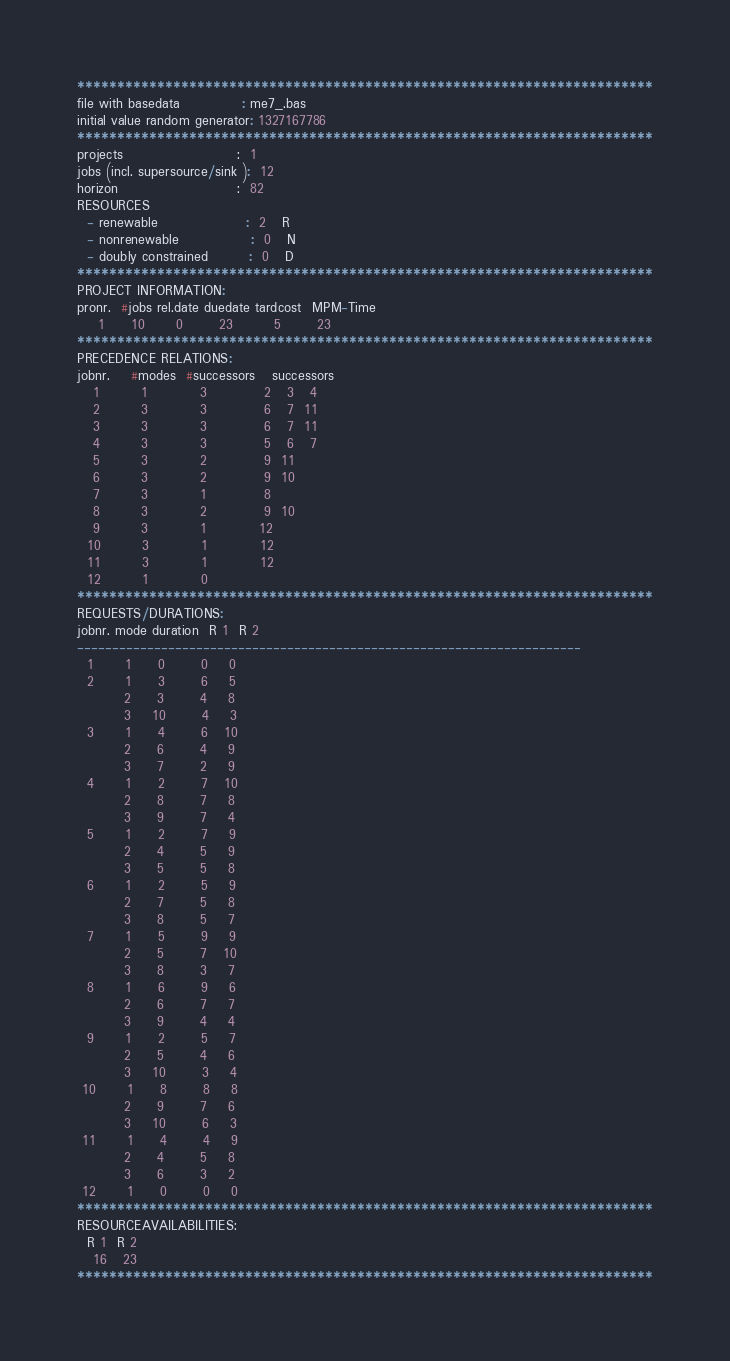<code> <loc_0><loc_0><loc_500><loc_500><_ObjectiveC_>************************************************************************
file with basedata            : me7_.bas
initial value random generator: 1327167786
************************************************************************
projects                      :  1
jobs (incl. supersource/sink ):  12
horizon                       :  82
RESOURCES
  - renewable                 :  2   R
  - nonrenewable              :  0   N
  - doubly constrained        :  0   D
************************************************************************
PROJECT INFORMATION:
pronr.  #jobs rel.date duedate tardcost  MPM-Time
    1     10      0       23        5       23
************************************************************************
PRECEDENCE RELATIONS:
jobnr.    #modes  #successors   successors
   1        1          3           2   3   4
   2        3          3           6   7  11
   3        3          3           6   7  11
   4        3          3           5   6   7
   5        3          2           9  11
   6        3          2           9  10
   7        3          1           8
   8        3          2           9  10
   9        3          1          12
  10        3          1          12
  11        3          1          12
  12        1          0        
************************************************************************
REQUESTS/DURATIONS:
jobnr. mode duration  R 1  R 2
------------------------------------------------------------------------
  1      1     0       0    0
  2      1     3       6    5
         2     3       4    8
         3    10       4    3
  3      1     4       6   10
         2     6       4    9
         3     7       2    9
  4      1     2       7   10
         2     8       7    8
         3     9       7    4
  5      1     2       7    9
         2     4       5    9
         3     5       5    8
  6      1     2       5    9
         2     7       5    8
         3     8       5    7
  7      1     5       9    9
         2     5       7   10
         3     8       3    7
  8      1     6       9    6
         2     6       7    7
         3     9       4    4
  9      1     2       5    7
         2     5       4    6
         3    10       3    4
 10      1     8       8    8
         2     9       7    6
         3    10       6    3
 11      1     4       4    9
         2     4       5    8
         3     6       3    2
 12      1     0       0    0
************************************************************************
RESOURCEAVAILABILITIES:
  R 1  R 2
   16   23
************************************************************************
</code> 